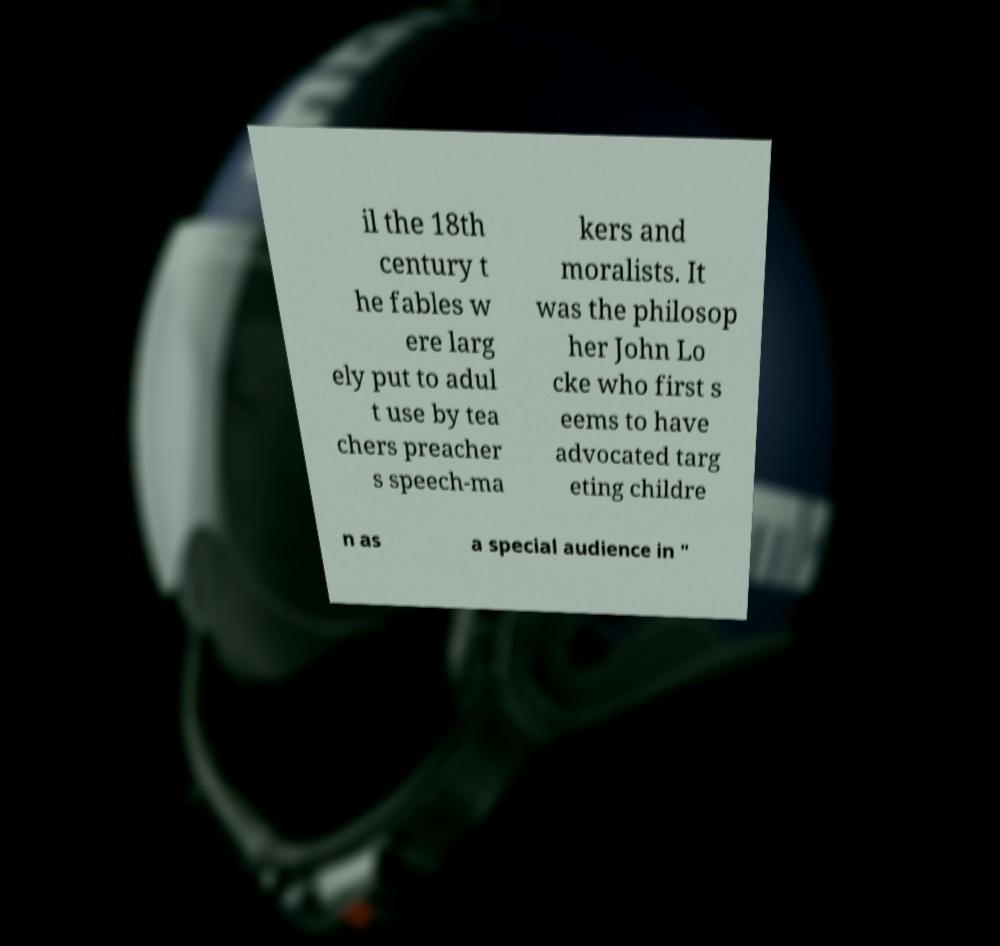Please identify and transcribe the text found in this image. il the 18th century t he fables w ere larg ely put to adul t use by tea chers preacher s speech-ma kers and moralists. It was the philosop her John Lo cke who first s eems to have advocated targ eting childre n as a special audience in " 